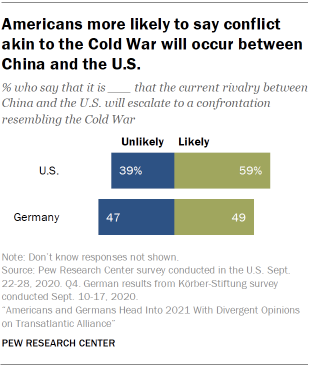Draw attention to some important aspects in this diagram. The sum of unlikely values in the US and Germany is not more likely in the US and Germany compared to the unlikely values in the US and Germany. There is a strong possibility that the rivalry between China and the US will escalate to a confrontation resembling the Cold War, as indicated by the survey results with a value of 59%. 